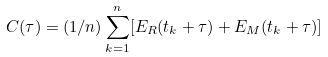Convert formula to latex. <formula><loc_0><loc_0><loc_500><loc_500>C ( \tau ) = ( 1 / n ) \sum _ { k = 1 } ^ { n } [ E _ { R } ( t _ { k } + \tau ) + E _ { M } ( t _ { k } + \tau ) ]</formula> 